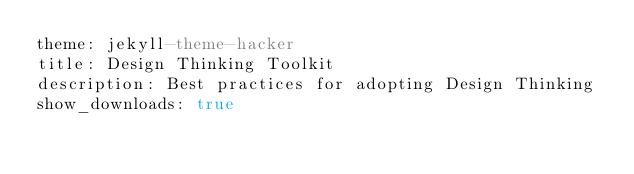<code> <loc_0><loc_0><loc_500><loc_500><_YAML_>theme: jekyll-theme-hacker
title: Design Thinking Toolkit
description: Best practices for adopting Design Thinking 
show_downloads: true
</code> 